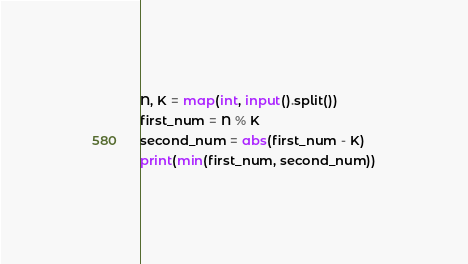<code> <loc_0><loc_0><loc_500><loc_500><_Python_>N, K = map(int, input().split())
first_num = N % K
second_num = abs(first_num - K)
print(min(first_num, second_num))</code> 